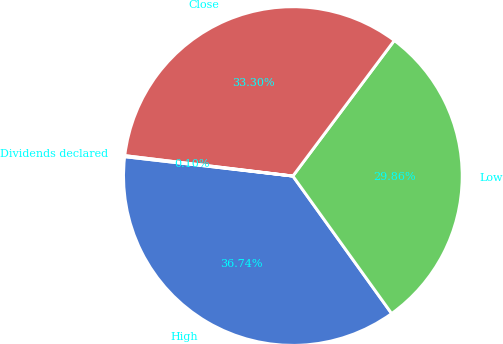Convert chart. <chart><loc_0><loc_0><loc_500><loc_500><pie_chart><fcel>High<fcel>Low<fcel>Close<fcel>Dividends declared<nl><fcel>36.74%<fcel>29.86%<fcel>33.3%<fcel>0.1%<nl></chart> 